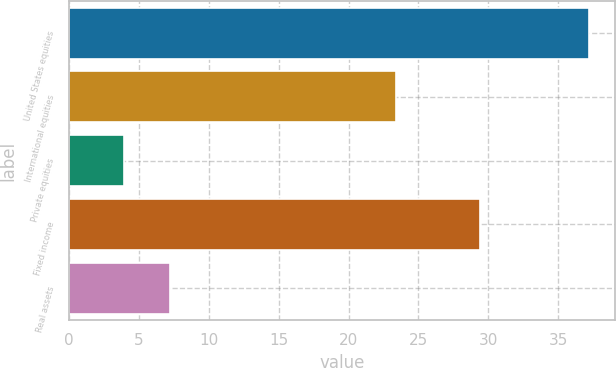<chart> <loc_0><loc_0><loc_500><loc_500><bar_chart><fcel>United States equities<fcel>International equities<fcel>Private equities<fcel>Fixed income<fcel>Real assets<nl><fcel>37.2<fcel>23.4<fcel>3.9<fcel>29.4<fcel>7.23<nl></chart> 